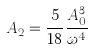<formula> <loc_0><loc_0><loc_500><loc_500>A _ { 2 } = \frac { 5 } { 1 8 } \frac { A _ { 0 } ^ { 3 } } { \omega ^ { 4 } }</formula> 